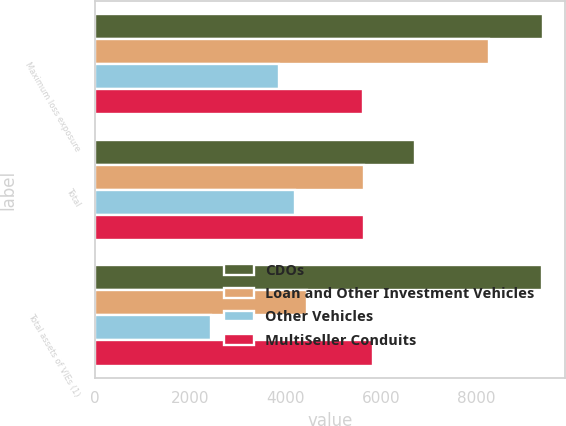Convert chart to OTSL. <chart><loc_0><loc_0><loc_500><loc_500><stacked_bar_chart><ecel><fcel>Maximum loss exposure<fcel>Total<fcel>Total assets of VIEs (1)<nl><fcel>CDOs<fcel>9388<fcel>6713<fcel>9368<nl><fcel>Loan and Other Investment Vehicles<fcel>8265<fcel>5650<fcel>4449<nl><fcel>Other Vehicles<fcel>3863<fcel>4199<fcel>2443<nl><fcel>MultiSeller Conduits<fcel>5634<fcel>5650<fcel>5829<nl></chart> 